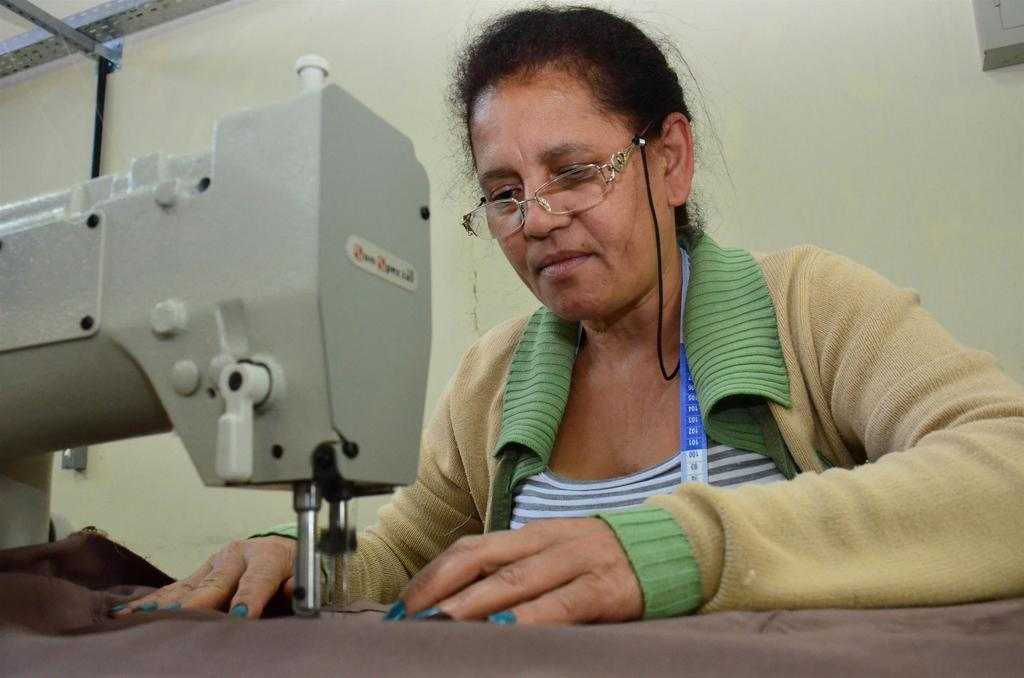Who is present in the image? There is a woman in the image. What is the woman doing in the image? The woman is using a sewing machine in the image. What materials are related to the woman's activity in the image? There is cloth and a measuring tape in the image. What can be seen on the woman's face in the image? The woman is wearing spectacles in the image. What is visible in the background of the image? There is a wall and objects visible in the background of the image. What type of volcano can be seen erupting in the background of the image? There is no volcano present in the image; it features a woman using a sewing machine with a wall and objects visible in the background. 